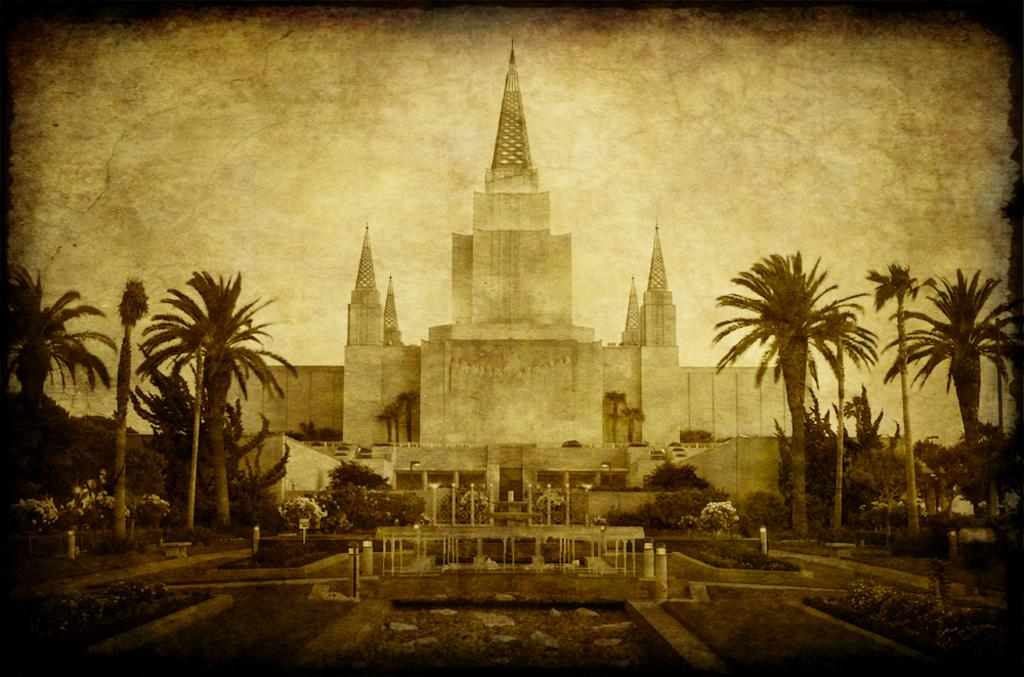What type of vegetation can be seen in the image? There are trees and plants with flowers in the image. What type of ground cover is present in the image? There is grass in the image. What structures can be seen in the image? There are poles in the image. What can be seen in the background of the image? There is a building, objects, and clouds in the sky in the background of the image. What type of meat is being rubbed with spices in the image? There is no meat or rubbing of spices present in the image. How much debt is visible on the building in the background of the image? There is no indication of debt on the building in the background of the image. 